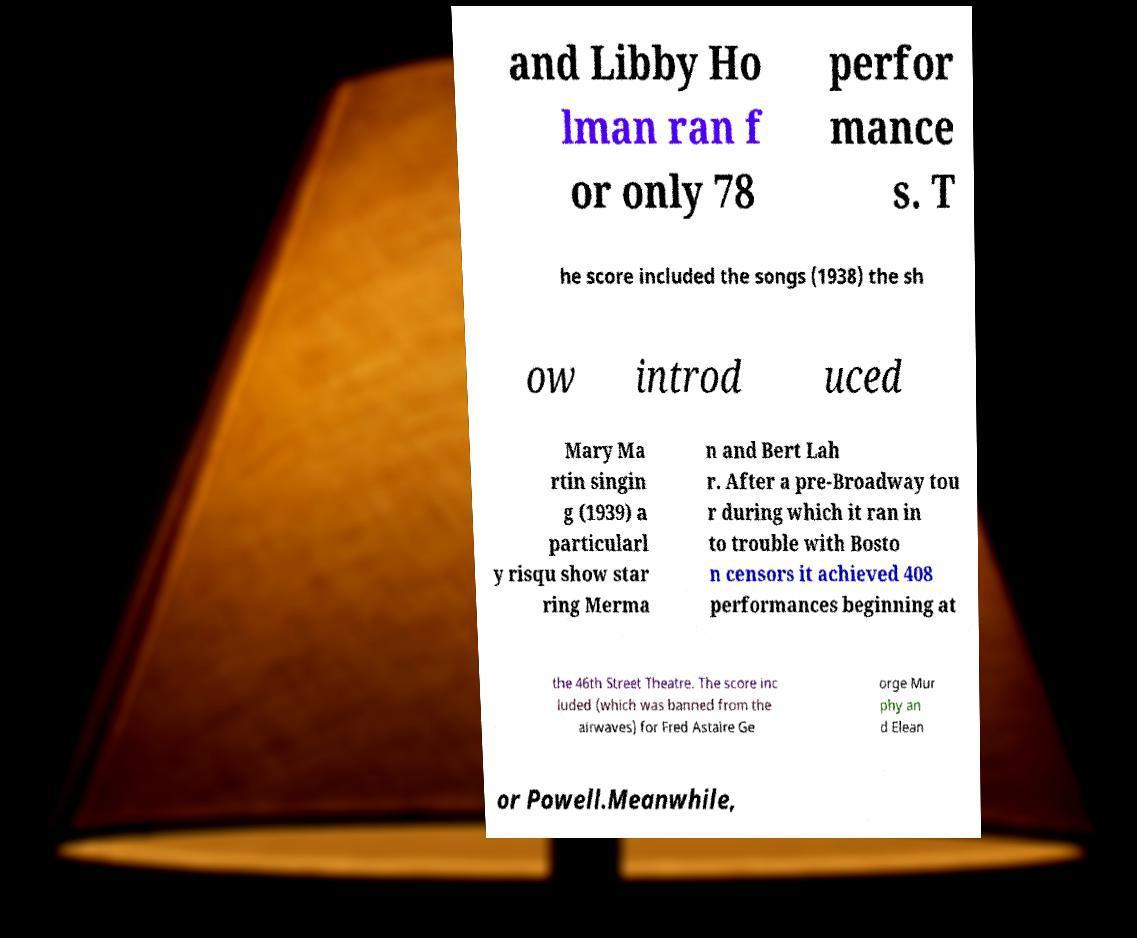Please identify and transcribe the text found in this image. and Libby Ho lman ran f or only 78 perfor mance s. T he score included the songs (1938) the sh ow introd uced Mary Ma rtin singin g (1939) a particularl y risqu show star ring Merma n and Bert Lah r. After a pre-Broadway tou r during which it ran in to trouble with Bosto n censors it achieved 408 performances beginning at the 46th Street Theatre. The score inc luded (which was banned from the airwaves) for Fred Astaire Ge orge Mur phy an d Elean or Powell.Meanwhile, 